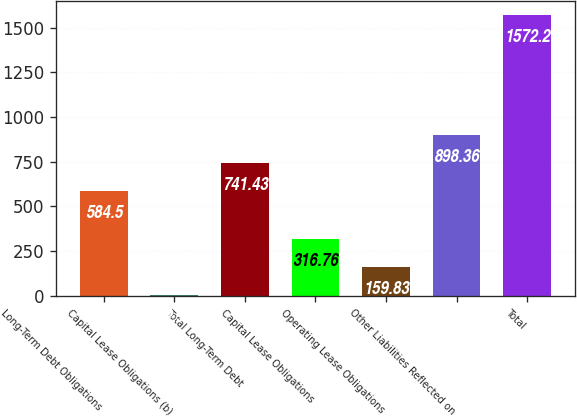Convert chart. <chart><loc_0><loc_0><loc_500><loc_500><bar_chart><fcel>Long-Term Debt Obligations<fcel>Capital Lease Obligations (b)<fcel>Total Long-Term Debt<fcel>Capital Lease Obligations<fcel>Operating Lease Obligations<fcel>Other Liabilities Reflected on<fcel>Total<nl><fcel>584.5<fcel>2.9<fcel>741.43<fcel>316.76<fcel>159.83<fcel>898.36<fcel>1572.2<nl></chart> 